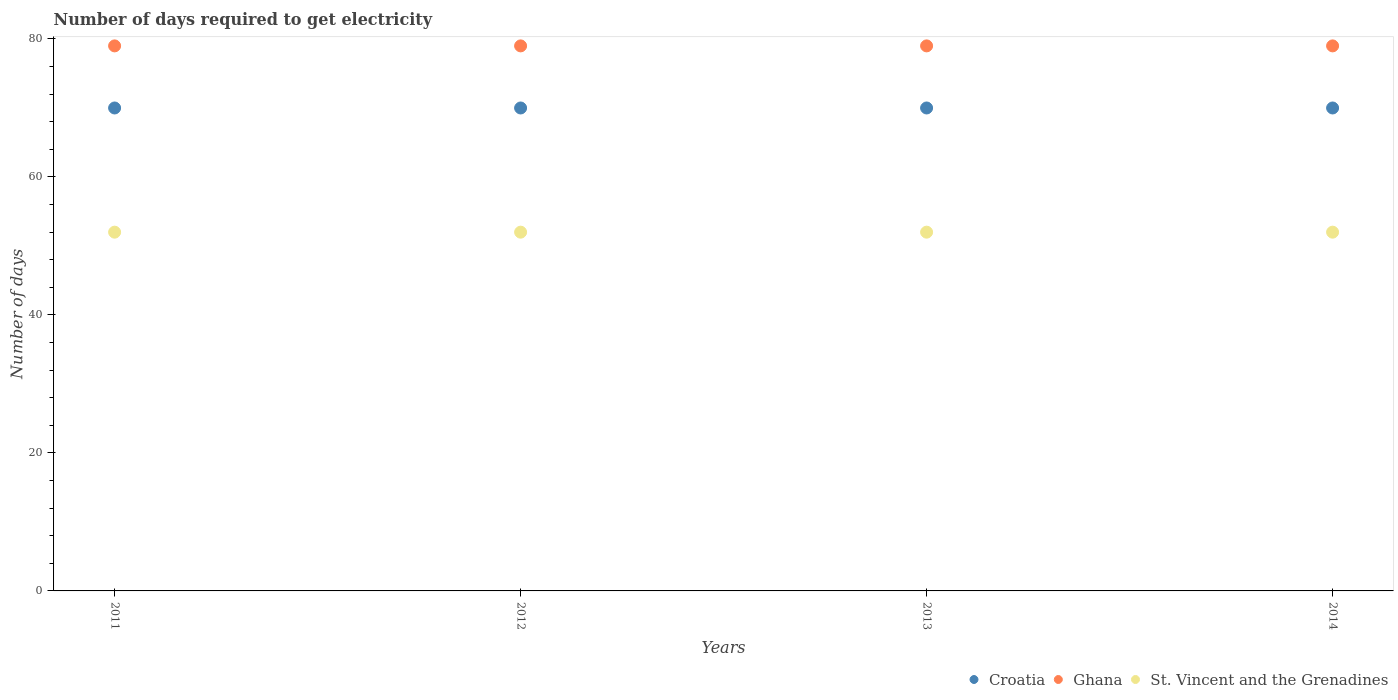How many different coloured dotlines are there?
Ensure brevity in your answer.  3. What is the number of days required to get electricity in in Ghana in 2014?
Make the answer very short. 79. Across all years, what is the maximum number of days required to get electricity in in St. Vincent and the Grenadines?
Ensure brevity in your answer.  52. Across all years, what is the minimum number of days required to get electricity in in Ghana?
Your answer should be very brief. 79. What is the total number of days required to get electricity in in Croatia in the graph?
Your response must be concise. 280. What is the difference between the number of days required to get electricity in in Croatia in 2011 and the number of days required to get electricity in in Ghana in 2014?
Make the answer very short. -9. What is the average number of days required to get electricity in in St. Vincent and the Grenadines per year?
Provide a succinct answer. 52. In the year 2013, what is the difference between the number of days required to get electricity in in Ghana and number of days required to get electricity in in St. Vincent and the Grenadines?
Your response must be concise. 27. In how many years, is the number of days required to get electricity in in St. Vincent and the Grenadines greater than 32 days?
Keep it short and to the point. 4. Is the number of days required to get electricity in in Ghana in 2012 less than that in 2014?
Your answer should be very brief. No. Is the difference between the number of days required to get electricity in in Ghana in 2011 and 2013 greater than the difference between the number of days required to get electricity in in St. Vincent and the Grenadines in 2011 and 2013?
Offer a terse response. No. Is it the case that in every year, the sum of the number of days required to get electricity in in Croatia and number of days required to get electricity in in Ghana  is greater than the number of days required to get electricity in in St. Vincent and the Grenadines?
Give a very brief answer. Yes. Does the number of days required to get electricity in in Ghana monotonically increase over the years?
Your answer should be very brief. No. Is the number of days required to get electricity in in St. Vincent and the Grenadines strictly greater than the number of days required to get electricity in in Croatia over the years?
Give a very brief answer. No. How many years are there in the graph?
Offer a very short reply. 4. Where does the legend appear in the graph?
Make the answer very short. Bottom right. How many legend labels are there?
Provide a short and direct response. 3. How are the legend labels stacked?
Provide a succinct answer. Horizontal. What is the title of the graph?
Give a very brief answer. Number of days required to get electricity. Does "Belarus" appear as one of the legend labels in the graph?
Make the answer very short. No. What is the label or title of the X-axis?
Give a very brief answer. Years. What is the label or title of the Y-axis?
Your response must be concise. Number of days. What is the Number of days in Croatia in 2011?
Ensure brevity in your answer.  70. What is the Number of days in Ghana in 2011?
Your answer should be compact. 79. What is the Number of days of St. Vincent and the Grenadines in 2011?
Your answer should be very brief. 52. What is the Number of days in Ghana in 2012?
Give a very brief answer. 79. What is the Number of days of St. Vincent and the Grenadines in 2012?
Provide a succinct answer. 52. What is the Number of days of Croatia in 2013?
Ensure brevity in your answer.  70. What is the Number of days in Ghana in 2013?
Your response must be concise. 79. What is the Number of days in St. Vincent and the Grenadines in 2013?
Your response must be concise. 52. What is the Number of days in Ghana in 2014?
Your answer should be compact. 79. Across all years, what is the maximum Number of days in Croatia?
Ensure brevity in your answer.  70. Across all years, what is the maximum Number of days in Ghana?
Provide a succinct answer. 79. Across all years, what is the maximum Number of days of St. Vincent and the Grenadines?
Provide a succinct answer. 52. Across all years, what is the minimum Number of days in Ghana?
Ensure brevity in your answer.  79. Across all years, what is the minimum Number of days of St. Vincent and the Grenadines?
Keep it short and to the point. 52. What is the total Number of days of Croatia in the graph?
Ensure brevity in your answer.  280. What is the total Number of days of Ghana in the graph?
Provide a succinct answer. 316. What is the total Number of days of St. Vincent and the Grenadines in the graph?
Offer a very short reply. 208. What is the difference between the Number of days in Croatia in 2011 and that in 2012?
Your answer should be very brief. 0. What is the difference between the Number of days of Ghana in 2011 and that in 2012?
Offer a terse response. 0. What is the difference between the Number of days of Croatia in 2011 and that in 2013?
Keep it short and to the point. 0. What is the difference between the Number of days in Ghana in 2011 and that in 2013?
Keep it short and to the point. 0. What is the difference between the Number of days in Ghana in 2012 and that in 2014?
Your answer should be very brief. 0. What is the difference between the Number of days in St. Vincent and the Grenadines in 2013 and that in 2014?
Your response must be concise. 0. What is the difference between the Number of days in Croatia in 2011 and the Number of days in St. Vincent and the Grenadines in 2012?
Provide a short and direct response. 18. What is the difference between the Number of days in Ghana in 2011 and the Number of days in St. Vincent and the Grenadines in 2012?
Give a very brief answer. 27. What is the difference between the Number of days in Croatia in 2011 and the Number of days in Ghana in 2013?
Keep it short and to the point. -9. What is the difference between the Number of days of Croatia in 2011 and the Number of days of St. Vincent and the Grenadines in 2013?
Ensure brevity in your answer.  18. What is the difference between the Number of days in Ghana in 2011 and the Number of days in St. Vincent and the Grenadines in 2013?
Keep it short and to the point. 27. What is the difference between the Number of days of Croatia in 2011 and the Number of days of Ghana in 2014?
Provide a succinct answer. -9. What is the difference between the Number of days in Croatia in 2012 and the Number of days in Ghana in 2014?
Give a very brief answer. -9. What is the difference between the Number of days in Croatia in 2012 and the Number of days in St. Vincent and the Grenadines in 2014?
Keep it short and to the point. 18. What is the difference between the Number of days in Croatia in 2013 and the Number of days in Ghana in 2014?
Ensure brevity in your answer.  -9. What is the average Number of days of Croatia per year?
Offer a very short reply. 70. What is the average Number of days of Ghana per year?
Keep it short and to the point. 79. In the year 2011, what is the difference between the Number of days in Croatia and Number of days in Ghana?
Ensure brevity in your answer.  -9. In the year 2012, what is the difference between the Number of days in Ghana and Number of days in St. Vincent and the Grenadines?
Your response must be concise. 27. In the year 2013, what is the difference between the Number of days of Croatia and Number of days of St. Vincent and the Grenadines?
Give a very brief answer. 18. In the year 2014, what is the difference between the Number of days of Croatia and Number of days of St. Vincent and the Grenadines?
Your response must be concise. 18. What is the ratio of the Number of days in Ghana in 2011 to that in 2012?
Your response must be concise. 1. What is the ratio of the Number of days in Croatia in 2011 to that in 2013?
Provide a short and direct response. 1. What is the ratio of the Number of days in St. Vincent and the Grenadines in 2011 to that in 2013?
Provide a succinct answer. 1. What is the ratio of the Number of days of Ghana in 2011 to that in 2014?
Provide a succinct answer. 1. What is the ratio of the Number of days in St. Vincent and the Grenadines in 2011 to that in 2014?
Provide a short and direct response. 1. What is the ratio of the Number of days of Ghana in 2012 to that in 2014?
Your response must be concise. 1. What is the ratio of the Number of days in Croatia in 2013 to that in 2014?
Your answer should be compact. 1. What is the difference between the highest and the second highest Number of days of St. Vincent and the Grenadines?
Provide a short and direct response. 0. What is the difference between the highest and the lowest Number of days in Croatia?
Your answer should be compact. 0. What is the difference between the highest and the lowest Number of days of Ghana?
Provide a succinct answer. 0. What is the difference between the highest and the lowest Number of days of St. Vincent and the Grenadines?
Ensure brevity in your answer.  0. 